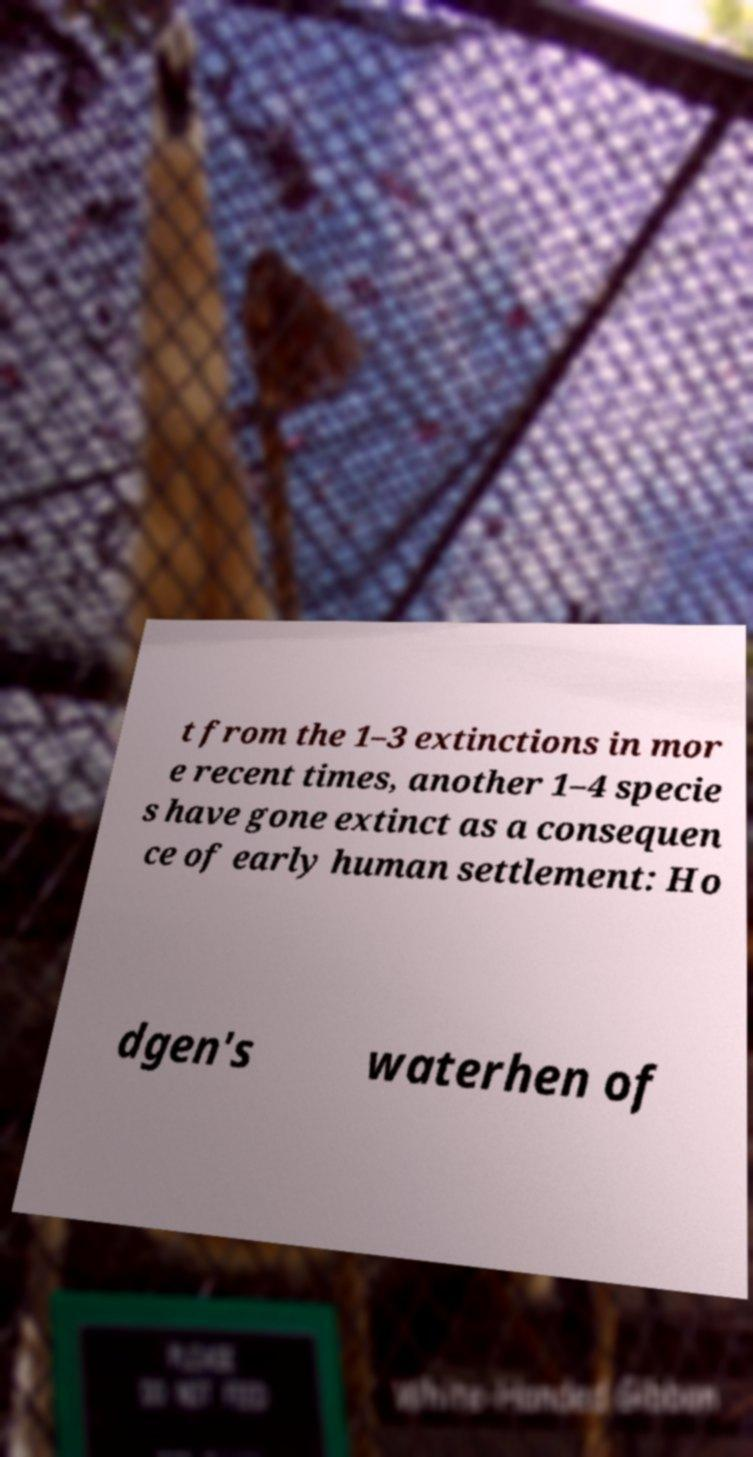Please identify and transcribe the text found in this image. t from the 1–3 extinctions in mor e recent times, another 1–4 specie s have gone extinct as a consequen ce of early human settlement: Ho dgen's waterhen of 